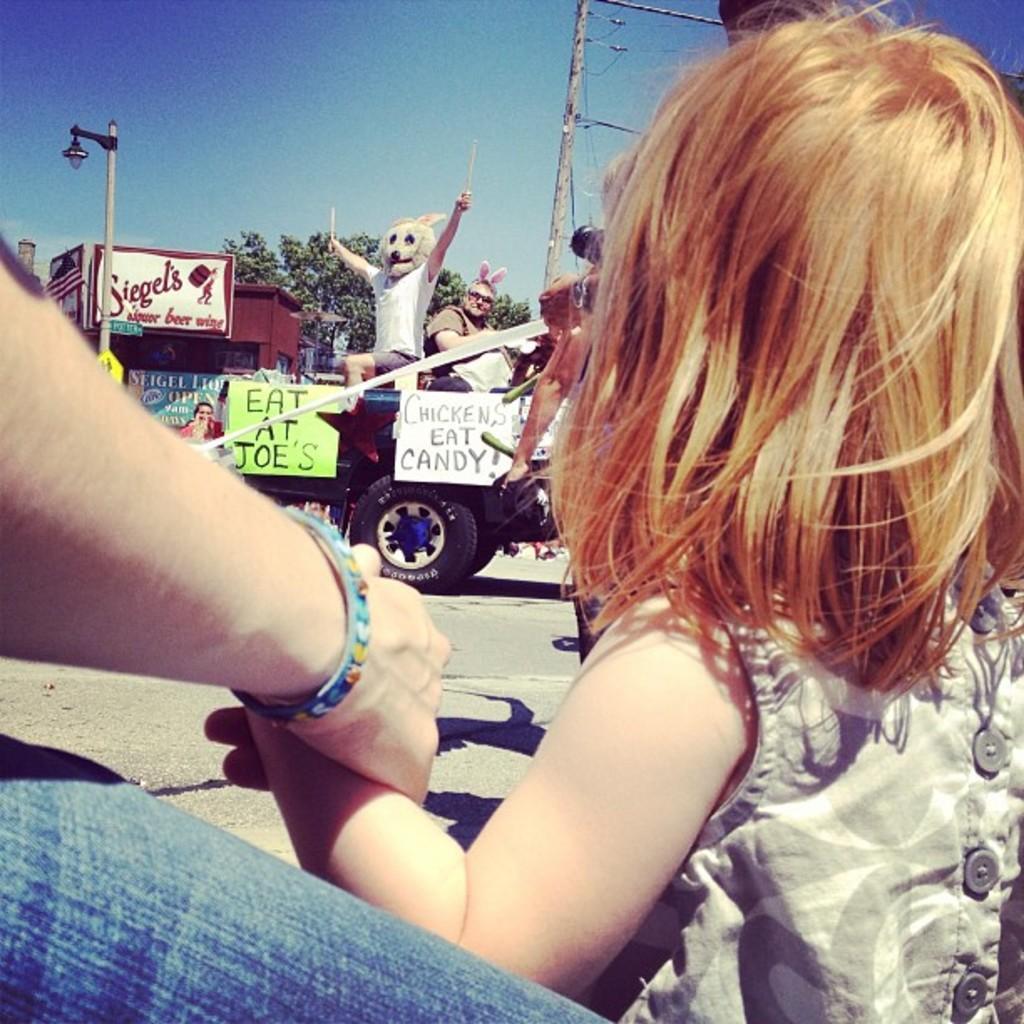How would you summarize this image in a sentence or two? In this image I can see few people with different color dresses. On the road there is a vehicle. On the vehicle I can see few more people with mask. And there are pipes attached to the vehicle. In the background I can see the house, trees, light pole and also the sky. 